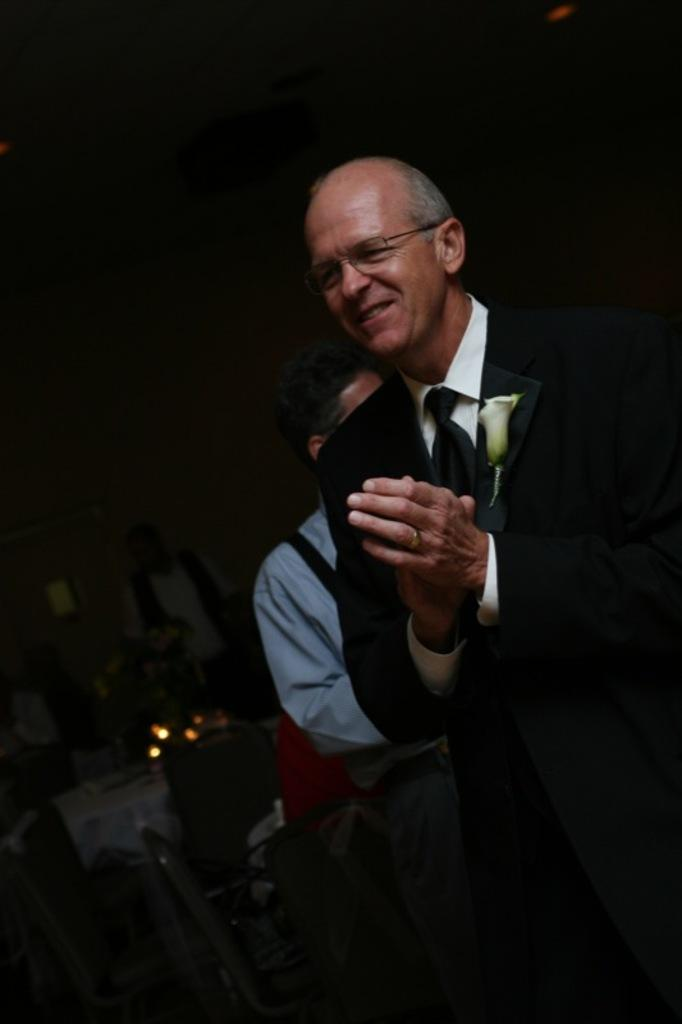What is the main subject of the image? There is a man standing in the image. What is the man doing in the image? The man is clapping his hands. What can be seen in the background of the image? There are people sitting on chairs in the background. How would you describe the lighting in the image? The background of the image is dark. What type of flowers can be seen growing in the image? There are no flowers present in the image. Can you describe the robin's nest in the image? There is no robin or nest present in the image. 